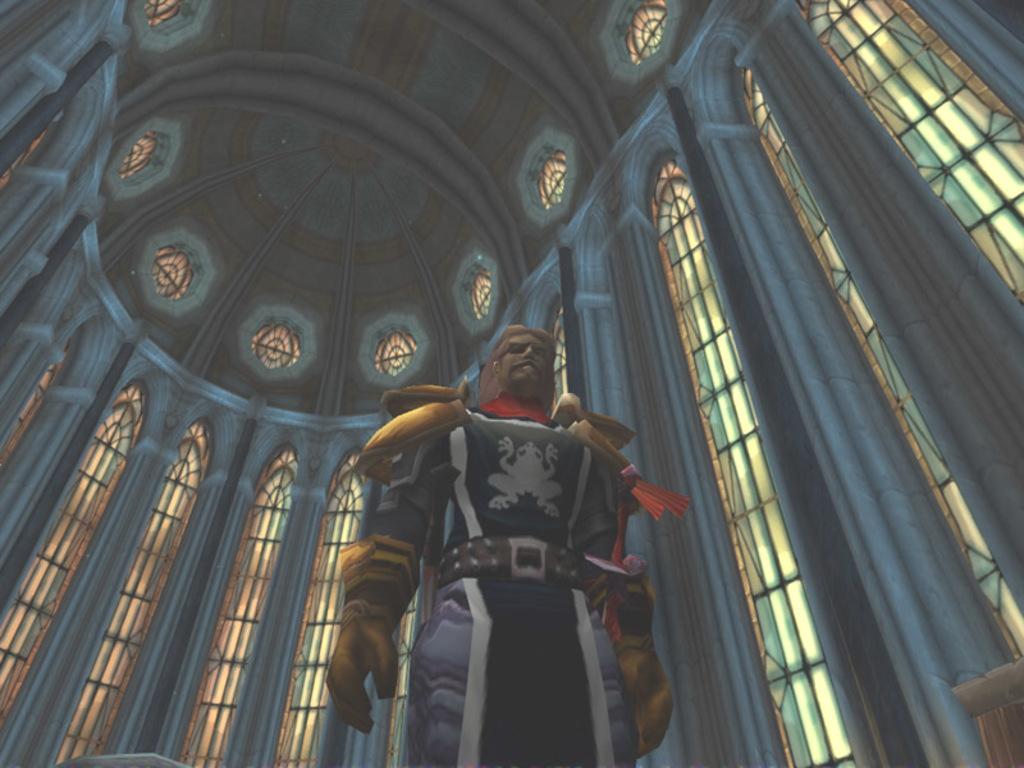Can you describe this image briefly? This is an animation, in this image in the center there is one person, and in the background there are windows, pillars, and at the top there is ceiling. 